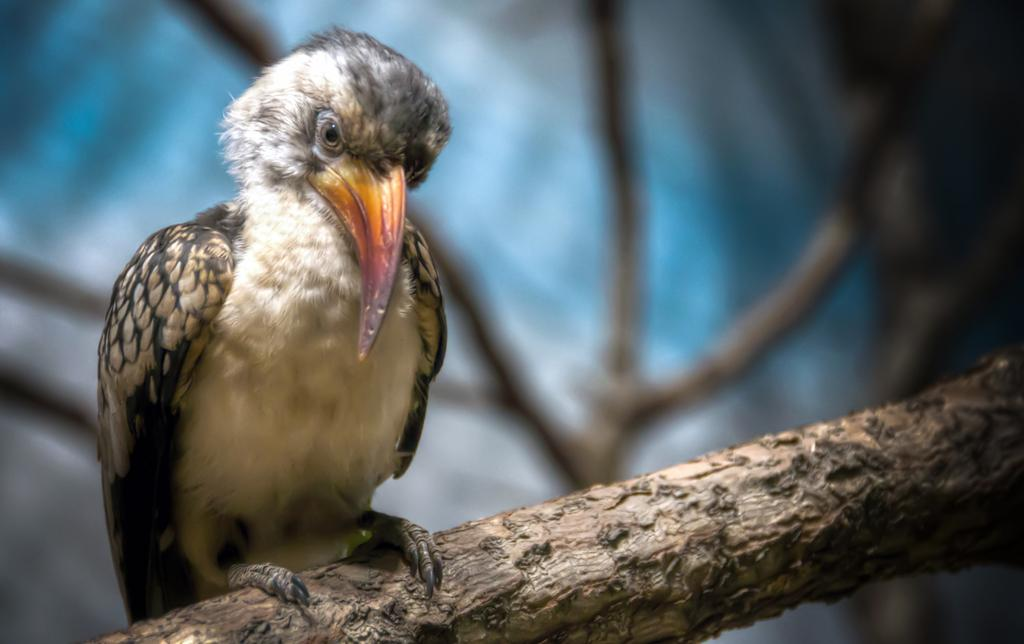What type of animal can be seen in the image? There is a bird in the image. Where is the bird located? The bird is on a branch. Can you describe the background of the image? The background of the image is blurred. What else can be seen in the image besides the bird? There are twigs visible in the image. What type of punishment is the bird receiving in the image? There is no indication of punishment in the image; the bird is simply perched on a branch. What type of fork can be seen in the image? There is no fork present in the image. 